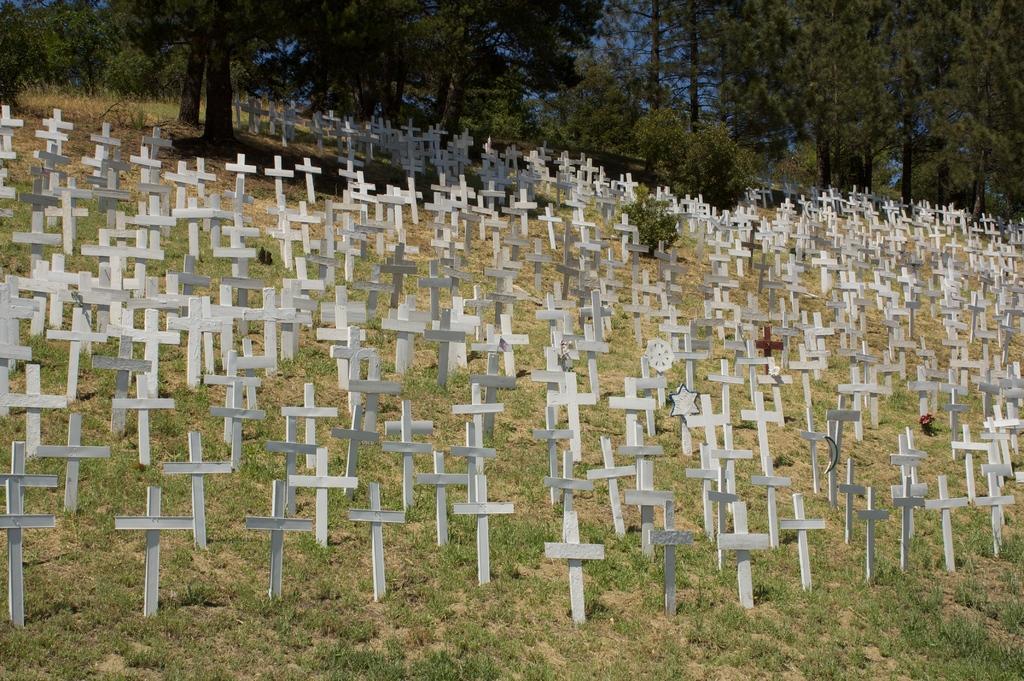How would you summarize this image in a sentence or two? In this picture we can see cross symbols, grass, plants and trees. In the background of the image we can see the sky. 